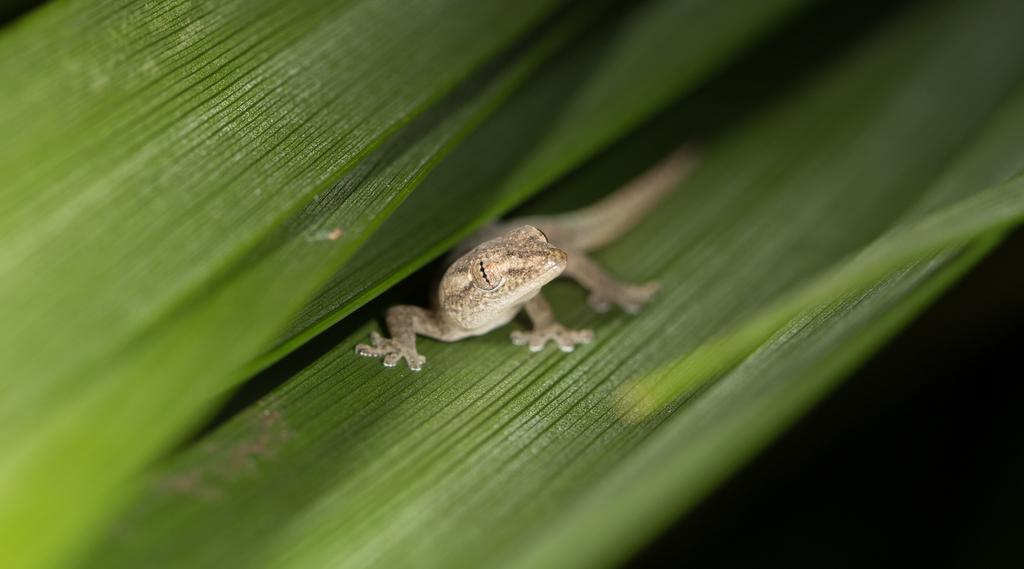What type of animal is in the image? There is a reptile in the image. Where is the reptile located? The reptile is on a green leaf. What type of voice does the ladybug have in the image? There is no ladybug present in the image, so it is not possible to determine the voice of any ladybug. 